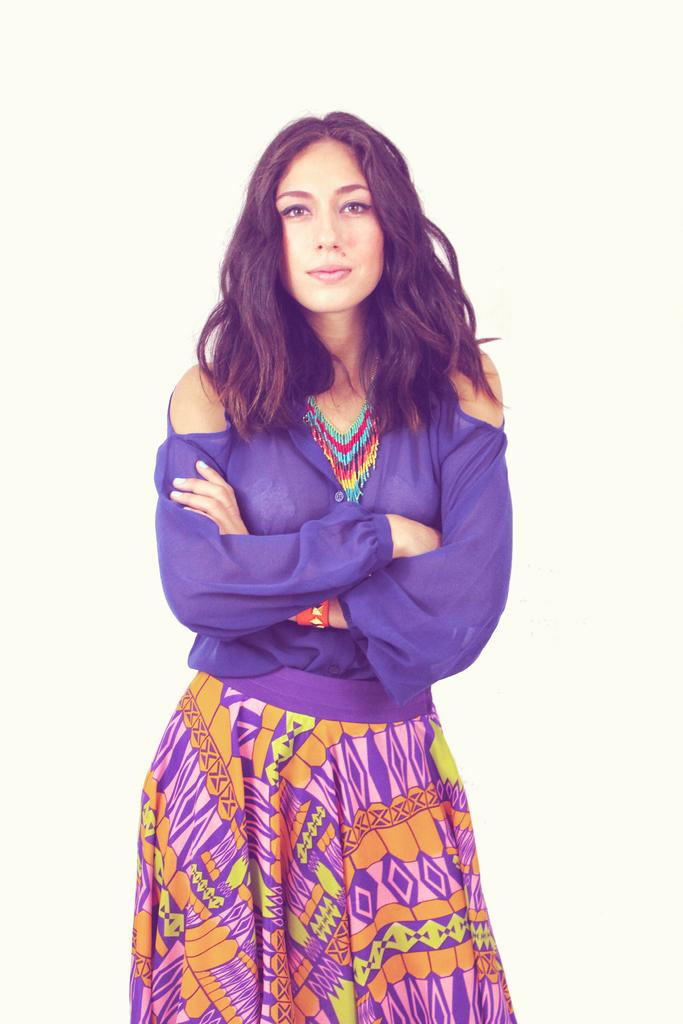Who is the main subject in the image? There is a woman in the image. What is the woman wearing? The woman is wearing a purple dress and a skirt. What accessory is the woman wearing? The woman is wearing a necklace. What is the woman doing in the image? The woman is standing. What color is the background of the image? The background of the image is white. How many houses are visible in the image? There are no houses visible in the image; it features a woman standing against a white background. What type of trouble is the woman facing in the image? There is no indication of trouble in the image; the woman is simply standing and wearing a purple dress, skirt, and necklace. 